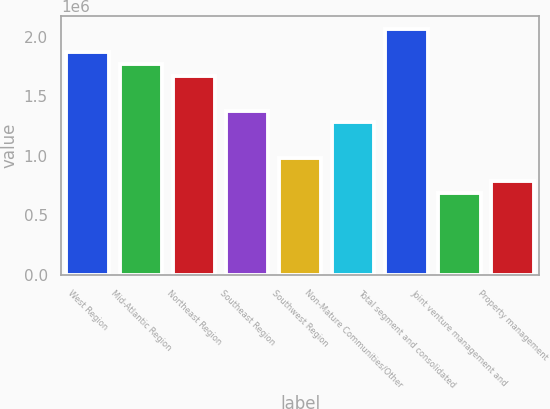Convert chart to OTSL. <chart><loc_0><loc_0><loc_500><loc_500><bar_chart><fcel>West Region<fcel>Mid-Atlantic Region<fcel>Northeast Region<fcel>Southeast Region<fcel>Southwest Region<fcel>Non-Mature Communities/Other<fcel>Total segment and consolidated<fcel>Joint venture management and<fcel>Property management<nl><fcel>1.87004e+06<fcel>1.77162e+06<fcel>1.67321e+06<fcel>1.37797e+06<fcel>984309<fcel>1.27955e+06<fcel>2.06687e+06<fcel>689066<fcel>787480<nl></chart> 